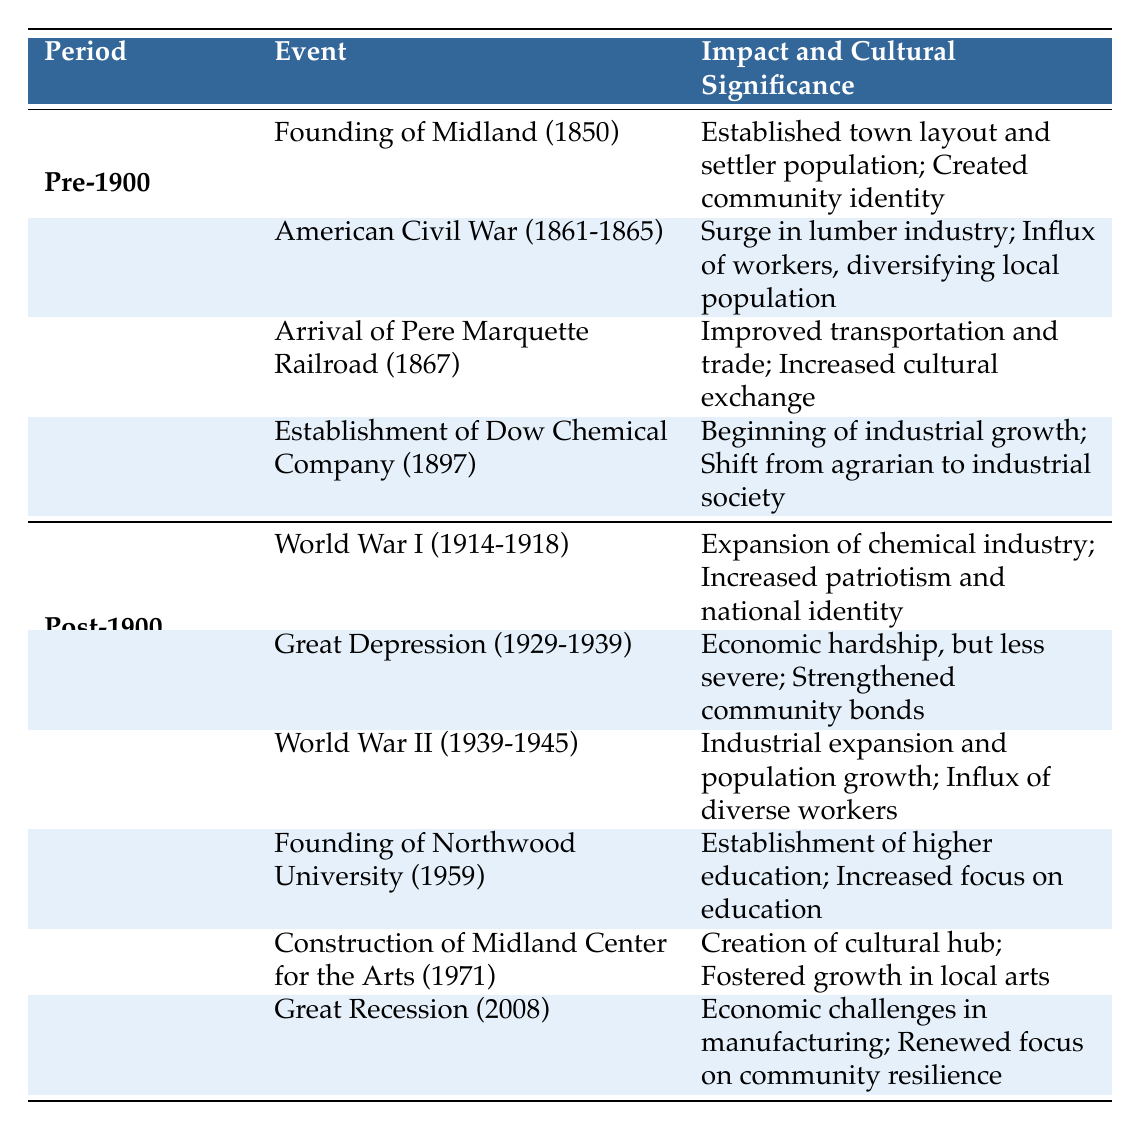What event marked the founding of Midland? The table indicates that the Founding of Midland occurred in 1850, establishing the town's initial layout and settler population.
Answer: Founding of Midland (1850) Which event resulted in a surge in the lumber industry? According to the table, the American Civil War (1861-1865) led to a surge in the lumber industry due to wartime demand.
Answer: American Civil War (1861-1865) Was the impact of the Great Depression more severe in Midland due to the presence of Dow Chemical Company? The table states that the Great Depression had less severe economic hardship in Midland due to the presence of Dow, indicating it was not more severe.
Answer: No How many events are listed under the Pre-1900 category? The table shows four events listed under Pre-1900: the founding of Midland, the American Civil War, the arrival of the Pere Marquette Railroad, and the establishment of Dow Chemical Company.
Answer: 4 What was the cultural significance of the establishment of Northwood University? The table notes that Northwood University, founded in 1959, increased focus on education and intellectual pursuits, highlighting its cultural importance.
Answer: Increased focus on education How does the influx of diverse workers during World War II compare to the impact of the American Civil War on the local population? The table indicates that both events led to an influx of diverse workers; the American Civil War diversified the local population through a surge in the lumber industry, while World War II's industrial expansion also brought in diverse workers, including women. So, both are significant in terms of cultural impact, but the context differs.
Answer: Similar impact; different contexts What event occurs between the Great Depression and the Great Recession? According to the table, World War II occurred between the Great Depression (1929-1939) and the Great Recession (2008), indicating its position in the timeline of events.
Answer: World War II (1939-1945) How many cultural hubs were created in Midland by 1971? The table specifies that the Midland Center for the Arts, constructed in 1971, served as a cultural hub, indicating only one such hub was noted by that date.
Answer: 1 What was the cultural significance of the construction of the Midland Center for the Arts? The table highlights that the Midland Center for the Arts fostered growth in local arts and performances, reflecting its importance to the cultural landscape.
Answer: Fostered growth in local arts 